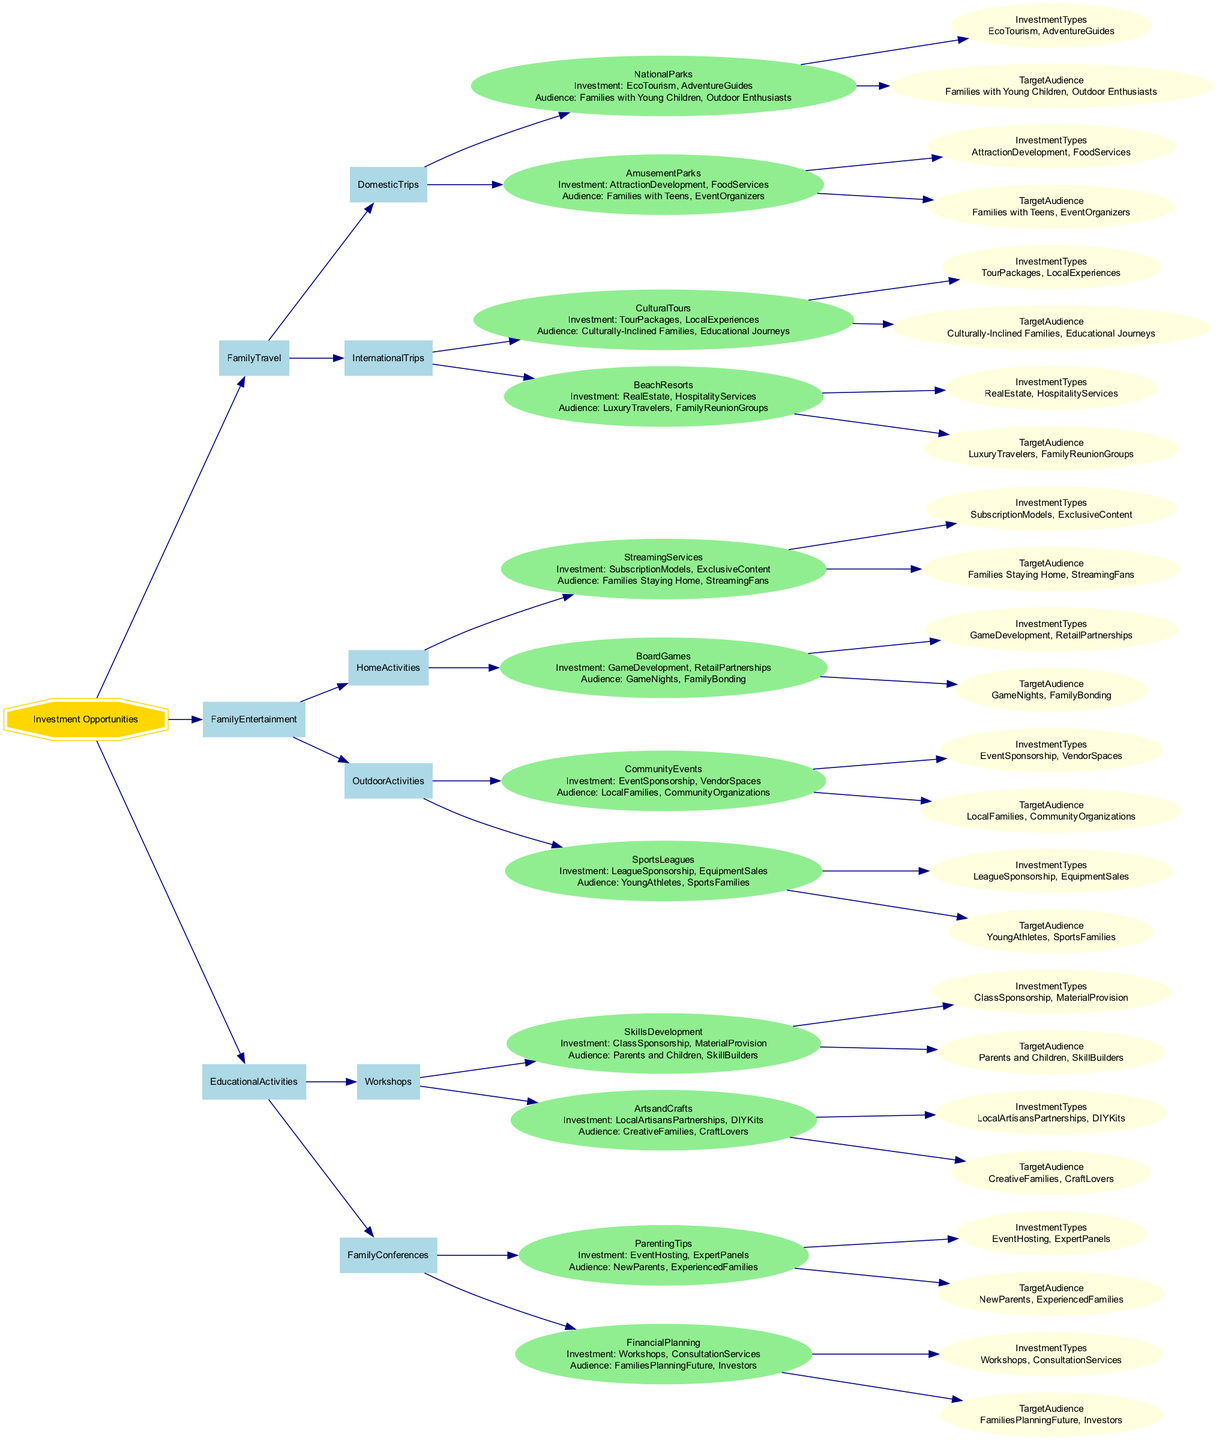What are the main categories of investment opportunities in the diagram? The diagram divides investment opportunities into three main categories: Family Travel, Family Entertainment, and Educational Activities.
Answer: Family Travel, Family Entertainment, Educational Activities How many investment types are associated with Family Travel? Under Family Travel, there are four different investment types listed: EcoTourism, AdventureGuides, AttractionDevelopment, and FoodServices.
Answer: 4 What type of audience is targeted by EcoTourism investments? EcoTourism investments target "Families with Young Children" and "Outdoor Enthusiasts" as their audiences.
Answer: Families with Young Children, Outdoor Enthusiasts Which investment type is associated with Board Games? The investment types associated with Board Games are "Game Development" and "Retail Partnerships".
Answer: Game Development, Retail Partnerships Which investment opportunity has the highest number of investment types? The "Workshops" category under "Educational Activities" has two subcategories, both listed with investment types, but they're less than the total number in Family Travel overall. Family Travel has four investment types, making it the category with the highest number.
Answer: Family Travel What type of activities does the Outdoor Activities category include? The Outdoor Activities category includes "Community Events" and "Sports Leagues".
Answer: Community Events, Sports Leagues What audience is targeted under Family Conferences related to Parenting Tips? The target audience for Family Conferences related to Parenting Tips includes "New Parents" and "Experienced Families".
Answer: New Parents, Experienced Families How many distinct categories of international trips are outlined? There are two distinct categories of international trips mentioned in the diagram: Cultural Tours and Beach Resorts.
Answer: 2 Which investment types are offered in Cultural Tours? The investment types related to Cultural Tours are "Tour Packages" and "Local Experiences".
Answer: Tour Packages, Local Experiences 